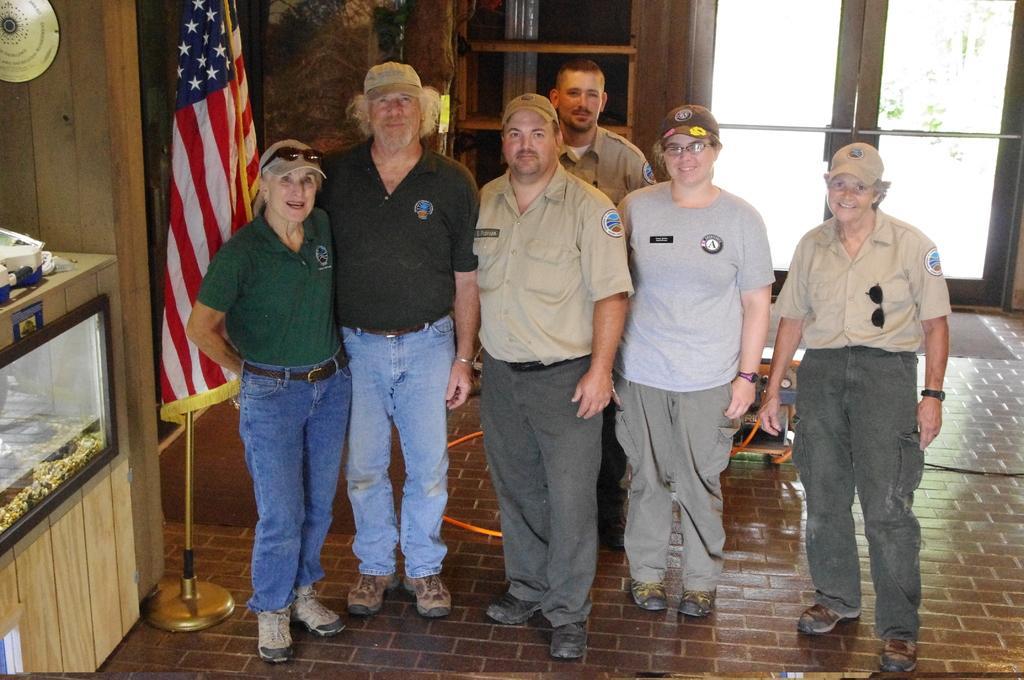In one or two sentences, can you explain what this image depicts? In this image I can see few people are standing and I can see except one rest all are wearing caps. I can also see three of them are wearing uniforms and behind them I can see doors. On the left side of this image I can see a glass box, a flag and a golden colour thing on the wall. 